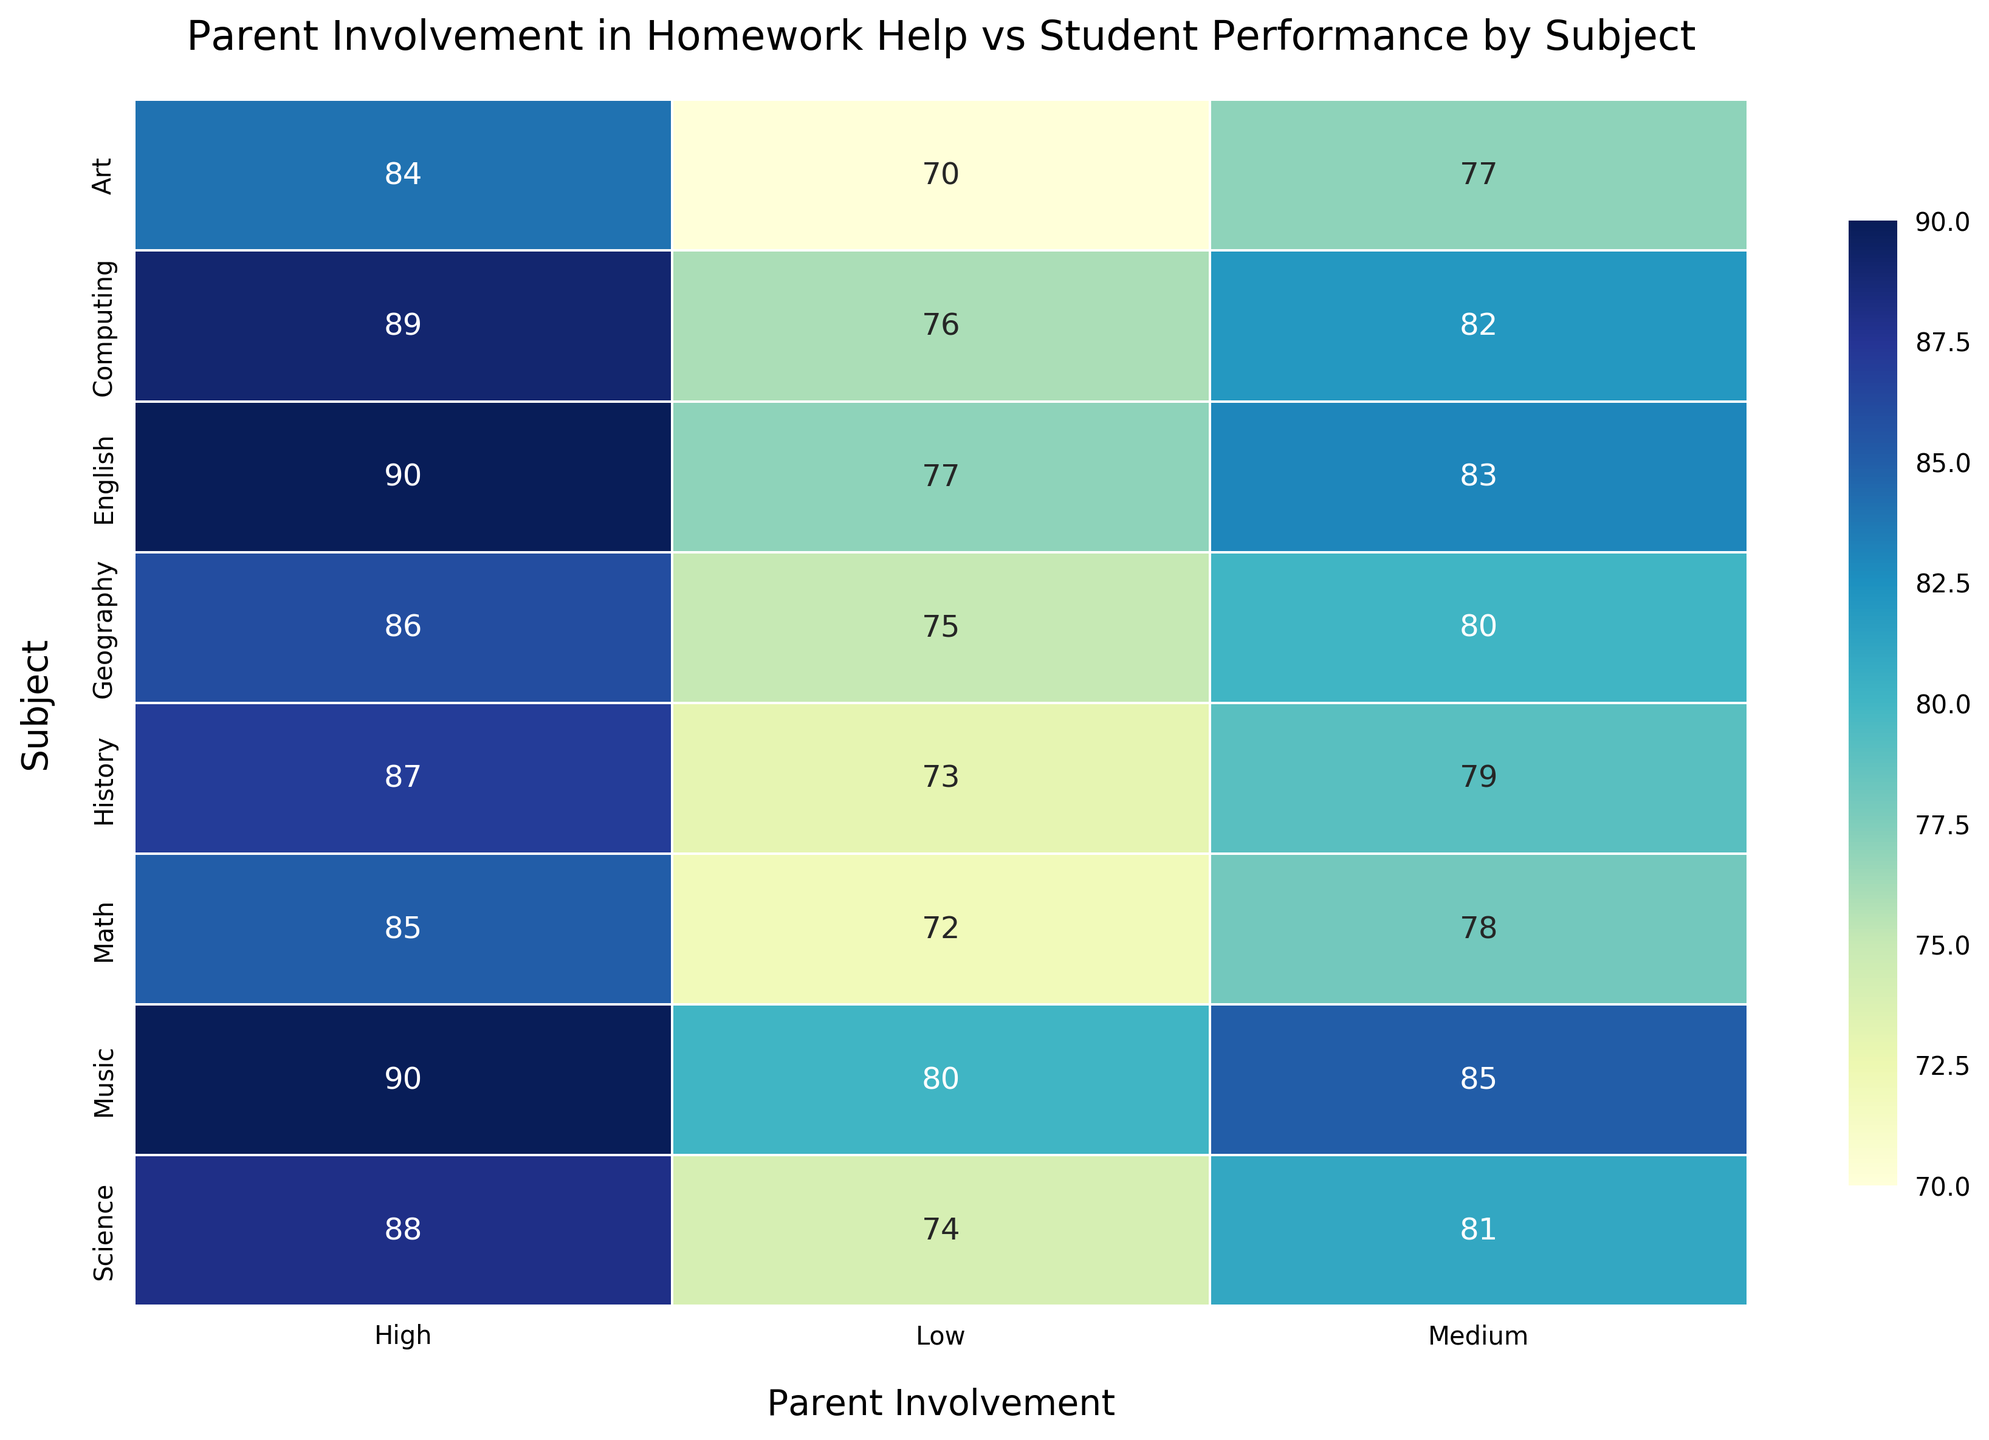How does student performance in the Math subject compare among different levels of parent involvement? To answer this, look at the student performance values for Math under High, Medium, and Low parent involvement categories. High involvement is associated with a performance score of 85, Medium has 78, and Low has 72.
Answer: High (85), Medium (78), Low (72) Which subject shows the highest student performance with Medium parent involvement? Find and compare the performance scores under Medium parent involvement for each subject. English has the highest score at 83.
Answer: English What's the difference in student performance for Geography between High and Low parent involvement? Look at the Geography row and subtract the Low involvement score from the High involvement score (86 - 75).
Answer: 11 Which subjects have at least a 10-point difference in performance between High and Low parent involvement? Identify the subjects where the difference between High and Low involvement is 10 points or more. These are Math (13), Science (14), Geography (11), Computing (13), Art (14), and Music (10).
Answer: Math, Science, Geography, Computing, Art, Music What is the average student performance in English across all levels of parent involvement? Sum the performance scores for English under High, Medium, and Low involvement (90 + 83 + 77 = 250) and divide by 3.
Answer: 83.33 How does the student performance in Music under Low parent involvement compare to Art under High parent involvement? Compare the performance score for Music with Low involvement (80) to Art with High involvement (84). Art has 4 points higher.
Answer: Art is higher by 4 points Which subject shows the highest student performance with Low parent involvement? Find the maximum value under Low parent involvement across all subjects. Music has the highest score at 80.
Answer: Music Is there a subject where the student performance does not show a high variance between High and Low levels of parent involvement? Look at the differences between High and Low scores. The lowest difference is in History with a 14-point difference, which is also notable but lesser than others with higher variances.
Answer: No, all subjects have noticeable variances 